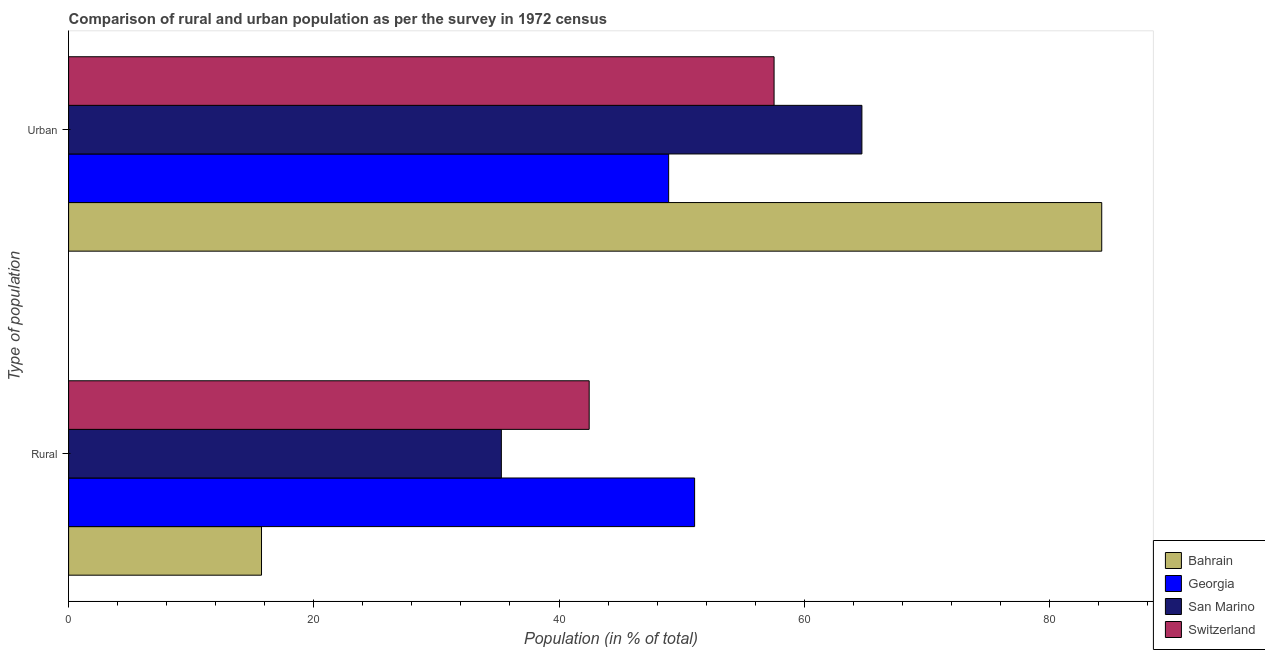How many groups of bars are there?
Your answer should be compact. 2. Are the number of bars on each tick of the Y-axis equal?
Keep it short and to the point. Yes. How many bars are there on the 2nd tick from the top?
Your answer should be compact. 4. What is the label of the 1st group of bars from the top?
Provide a succinct answer. Urban. What is the rural population in Bahrain?
Your answer should be compact. 15.73. Across all countries, what is the maximum rural population?
Provide a short and direct response. 51.06. Across all countries, what is the minimum rural population?
Your answer should be compact. 15.73. In which country was the rural population maximum?
Offer a terse response. Georgia. In which country was the rural population minimum?
Offer a very short reply. Bahrain. What is the total rural population in the graph?
Keep it short and to the point. 144.55. What is the difference between the rural population in San Marino and that in Bahrain?
Your answer should be compact. 19.56. What is the difference between the urban population in San Marino and the rural population in Georgia?
Ensure brevity in your answer.  13.65. What is the average rural population per country?
Ensure brevity in your answer.  36.14. What is the difference between the urban population and rural population in Georgia?
Keep it short and to the point. -2.12. In how many countries, is the urban population greater than 84 %?
Offer a terse response. 1. What is the ratio of the urban population in Bahrain to that in Georgia?
Keep it short and to the point. 1.72. Is the rural population in San Marino less than that in Switzerland?
Offer a terse response. Yes. What does the 4th bar from the top in Urban represents?
Your response must be concise. Bahrain. What does the 2nd bar from the bottom in Rural represents?
Your answer should be very brief. Georgia. How many bars are there?
Keep it short and to the point. 8. How many countries are there in the graph?
Ensure brevity in your answer.  4. Are the values on the major ticks of X-axis written in scientific E-notation?
Provide a succinct answer. No. Does the graph contain grids?
Ensure brevity in your answer.  No. What is the title of the graph?
Provide a short and direct response. Comparison of rural and urban population as per the survey in 1972 census. Does "Senegal" appear as one of the legend labels in the graph?
Keep it short and to the point. No. What is the label or title of the X-axis?
Give a very brief answer. Population (in % of total). What is the label or title of the Y-axis?
Your answer should be very brief. Type of population. What is the Population (in % of total) in Bahrain in Rural?
Keep it short and to the point. 15.73. What is the Population (in % of total) in Georgia in Rural?
Give a very brief answer. 51.06. What is the Population (in % of total) of San Marino in Rural?
Ensure brevity in your answer.  35.3. What is the Population (in % of total) in Switzerland in Rural?
Your answer should be compact. 42.46. What is the Population (in % of total) of Bahrain in Urban?
Your response must be concise. 84.27. What is the Population (in % of total) of Georgia in Urban?
Keep it short and to the point. 48.94. What is the Population (in % of total) of San Marino in Urban?
Your answer should be compact. 64.7. What is the Population (in % of total) in Switzerland in Urban?
Provide a short and direct response. 57.54. Across all Type of population, what is the maximum Population (in % of total) of Bahrain?
Give a very brief answer. 84.27. Across all Type of population, what is the maximum Population (in % of total) of Georgia?
Your response must be concise. 51.06. Across all Type of population, what is the maximum Population (in % of total) in San Marino?
Provide a short and direct response. 64.7. Across all Type of population, what is the maximum Population (in % of total) of Switzerland?
Give a very brief answer. 57.54. Across all Type of population, what is the minimum Population (in % of total) in Bahrain?
Make the answer very short. 15.73. Across all Type of population, what is the minimum Population (in % of total) in Georgia?
Provide a short and direct response. 48.94. Across all Type of population, what is the minimum Population (in % of total) in San Marino?
Offer a terse response. 35.3. Across all Type of population, what is the minimum Population (in % of total) in Switzerland?
Provide a succinct answer. 42.46. What is the total Population (in % of total) of Bahrain in the graph?
Provide a short and direct response. 100. What is the difference between the Population (in % of total) in Bahrain in Rural and that in Urban?
Your answer should be very brief. -68.53. What is the difference between the Population (in % of total) of Georgia in Rural and that in Urban?
Provide a short and direct response. 2.12. What is the difference between the Population (in % of total) in San Marino in Rural and that in Urban?
Keep it short and to the point. -29.41. What is the difference between the Population (in % of total) of Switzerland in Rural and that in Urban?
Make the answer very short. -15.08. What is the difference between the Population (in % of total) in Bahrain in Rural and the Population (in % of total) in Georgia in Urban?
Your response must be concise. -33.21. What is the difference between the Population (in % of total) in Bahrain in Rural and the Population (in % of total) in San Marino in Urban?
Make the answer very short. -48.97. What is the difference between the Population (in % of total) in Bahrain in Rural and the Population (in % of total) in Switzerland in Urban?
Ensure brevity in your answer.  -41.8. What is the difference between the Population (in % of total) in Georgia in Rural and the Population (in % of total) in San Marino in Urban?
Keep it short and to the point. -13.64. What is the difference between the Population (in % of total) in Georgia in Rural and the Population (in % of total) in Switzerland in Urban?
Your answer should be compact. -6.48. What is the difference between the Population (in % of total) in San Marino in Rural and the Population (in % of total) in Switzerland in Urban?
Your response must be concise. -22.24. What is the average Population (in % of total) of Bahrain per Type of population?
Provide a short and direct response. 50. What is the average Population (in % of total) in Georgia per Type of population?
Your answer should be very brief. 50. What is the average Population (in % of total) of Switzerland per Type of population?
Offer a terse response. 50. What is the difference between the Population (in % of total) of Bahrain and Population (in % of total) of Georgia in Rural?
Offer a very short reply. -35.32. What is the difference between the Population (in % of total) of Bahrain and Population (in % of total) of San Marino in Rural?
Give a very brief answer. -19.56. What is the difference between the Population (in % of total) of Bahrain and Population (in % of total) of Switzerland in Rural?
Your answer should be compact. -26.73. What is the difference between the Population (in % of total) of Georgia and Population (in % of total) of San Marino in Rural?
Provide a short and direct response. 15.76. What is the difference between the Population (in % of total) of Georgia and Population (in % of total) of Switzerland in Rural?
Offer a very short reply. 8.6. What is the difference between the Population (in % of total) in San Marino and Population (in % of total) in Switzerland in Rural?
Your answer should be compact. -7.16. What is the difference between the Population (in % of total) in Bahrain and Population (in % of total) in Georgia in Urban?
Give a very brief answer. 35.32. What is the difference between the Population (in % of total) of Bahrain and Population (in % of total) of San Marino in Urban?
Keep it short and to the point. 19.56. What is the difference between the Population (in % of total) in Bahrain and Population (in % of total) in Switzerland in Urban?
Your answer should be compact. 26.73. What is the difference between the Population (in % of total) in Georgia and Population (in % of total) in San Marino in Urban?
Provide a succinct answer. -15.76. What is the difference between the Population (in % of total) in Georgia and Population (in % of total) in Switzerland in Urban?
Keep it short and to the point. -8.6. What is the difference between the Population (in % of total) of San Marino and Population (in % of total) of Switzerland in Urban?
Provide a succinct answer. 7.16. What is the ratio of the Population (in % of total) of Bahrain in Rural to that in Urban?
Provide a succinct answer. 0.19. What is the ratio of the Population (in % of total) of Georgia in Rural to that in Urban?
Keep it short and to the point. 1.04. What is the ratio of the Population (in % of total) of San Marino in Rural to that in Urban?
Your answer should be compact. 0.55. What is the ratio of the Population (in % of total) of Switzerland in Rural to that in Urban?
Your answer should be compact. 0.74. What is the difference between the highest and the second highest Population (in % of total) of Bahrain?
Your answer should be compact. 68.53. What is the difference between the highest and the second highest Population (in % of total) in Georgia?
Provide a short and direct response. 2.12. What is the difference between the highest and the second highest Population (in % of total) in San Marino?
Your response must be concise. 29.41. What is the difference between the highest and the second highest Population (in % of total) in Switzerland?
Your answer should be compact. 15.08. What is the difference between the highest and the lowest Population (in % of total) of Bahrain?
Your answer should be compact. 68.53. What is the difference between the highest and the lowest Population (in % of total) in Georgia?
Ensure brevity in your answer.  2.12. What is the difference between the highest and the lowest Population (in % of total) of San Marino?
Offer a terse response. 29.41. What is the difference between the highest and the lowest Population (in % of total) of Switzerland?
Your answer should be very brief. 15.08. 